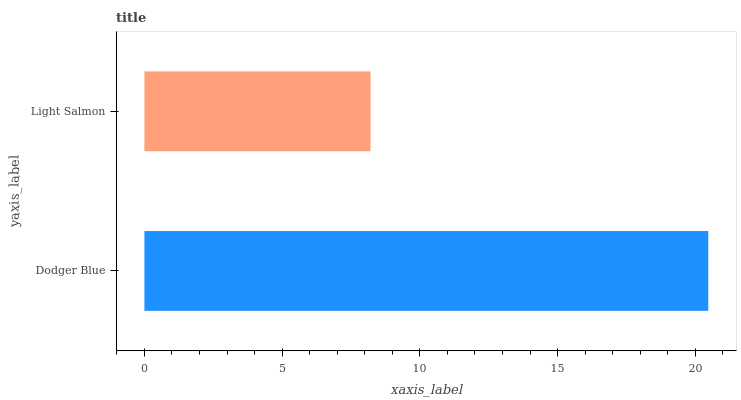Is Light Salmon the minimum?
Answer yes or no. Yes. Is Dodger Blue the maximum?
Answer yes or no. Yes. Is Light Salmon the maximum?
Answer yes or no. No. Is Dodger Blue greater than Light Salmon?
Answer yes or no. Yes. Is Light Salmon less than Dodger Blue?
Answer yes or no. Yes. Is Light Salmon greater than Dodger Blue?
Answer yes or no. No. Is Dodger Blue less than Light Salmon?
Answer yes or no. No. Is Dodger Blue the high median?
Answer yes or no. Yes. Is Light Salmon the low median?
Answer yes or no. Yes. Is Light Salmon the high median?
Answer yes or no. No. Is Dodger Blue the low median?
Answer yes or no. No. 